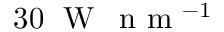Convert formula to latex. <formula><loc_0><loc_0><loc_500><loc_500>3 0 \, W \, n m ^ { - 1 }</formula> 